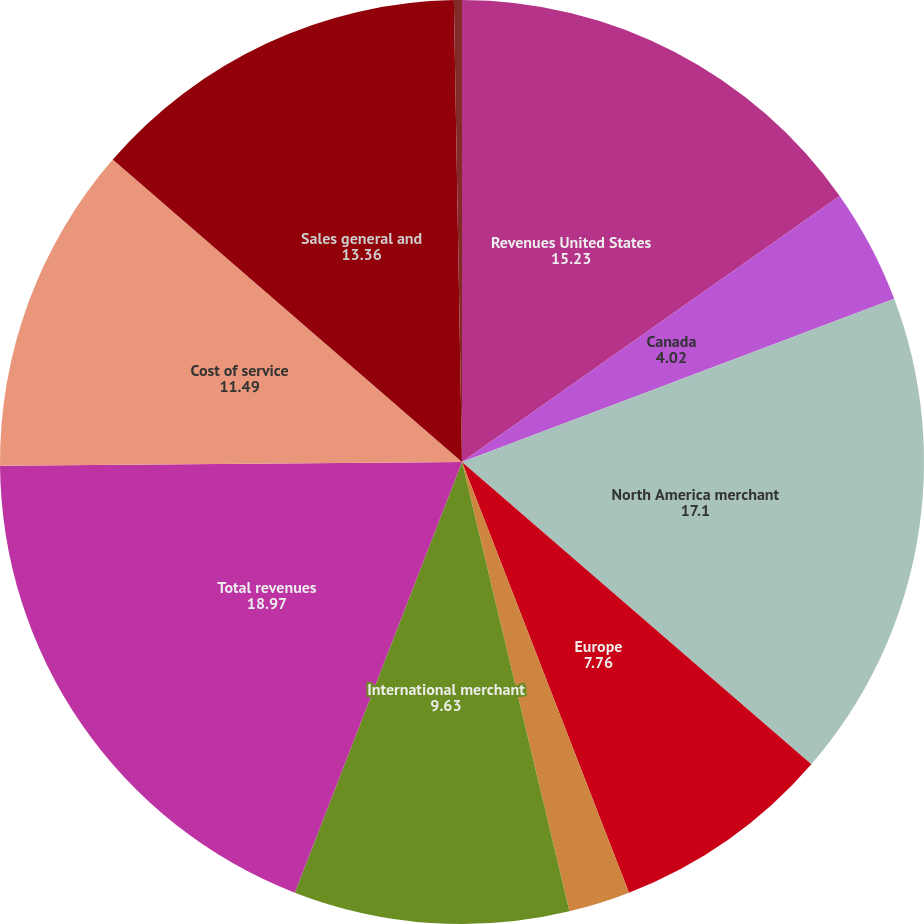Convert chart. <chart><loc_0><loc_0><loc_500><loc_500><pie_chart><fcel>Revenues United States<fcel>Canada<fcel>North America merchant<fcel>Europe<fcel>Asia-Pacific<fcel>International merchant<fcel>Total revenues<fcel>Cost of service<fcel>Sales general and<fcel>Processing system intrusion<nl><fcel>15.23%<fcel>4.02%<fcel>17.1%<fcel>7.76%<fcel>2.15%<fcel>9.63%<fcel>18.97%<fcel>11.49%<fcel>13.36%<fcel>0.28%<nl></chart> 